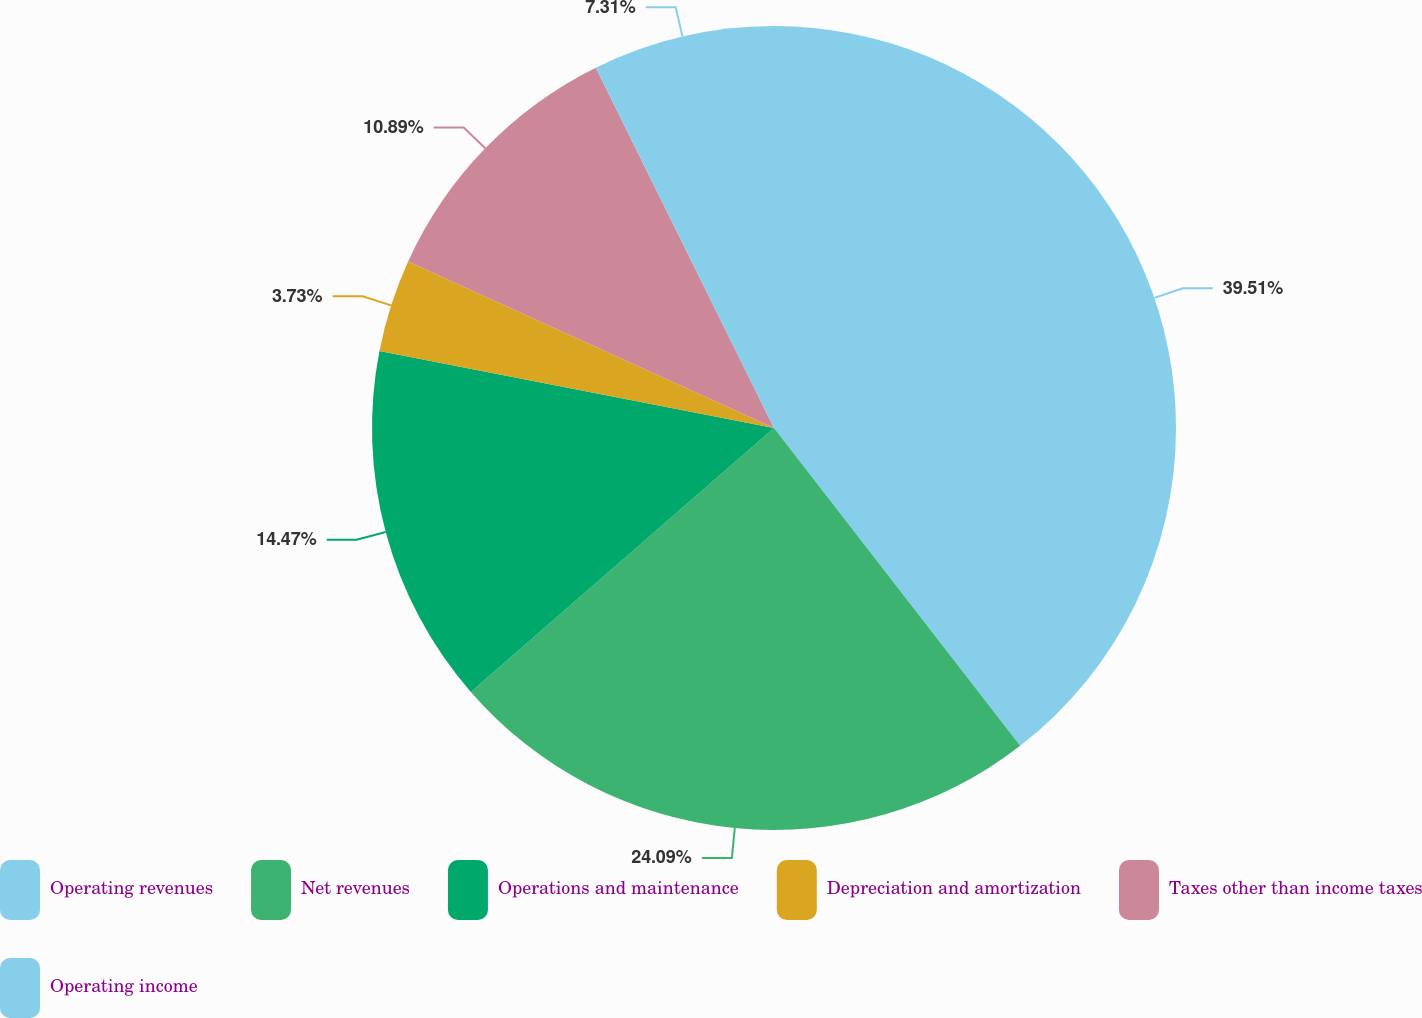<chart> <loc_0><loc_0><loc_500><loc_500><pie_chart><fcel>Operating revenues<fcel>Net revenues<fcel>Operations and maintenance<fcel>Depreciation and amortization<fcel>Taxes other than income taxes<fcel>Operating income<nl><fcel>39.51%<fcel>24.09%<fcel>14.47%<fcel>3.73%<fcel>10.89%<fcel>7.31%<nl></chart> 